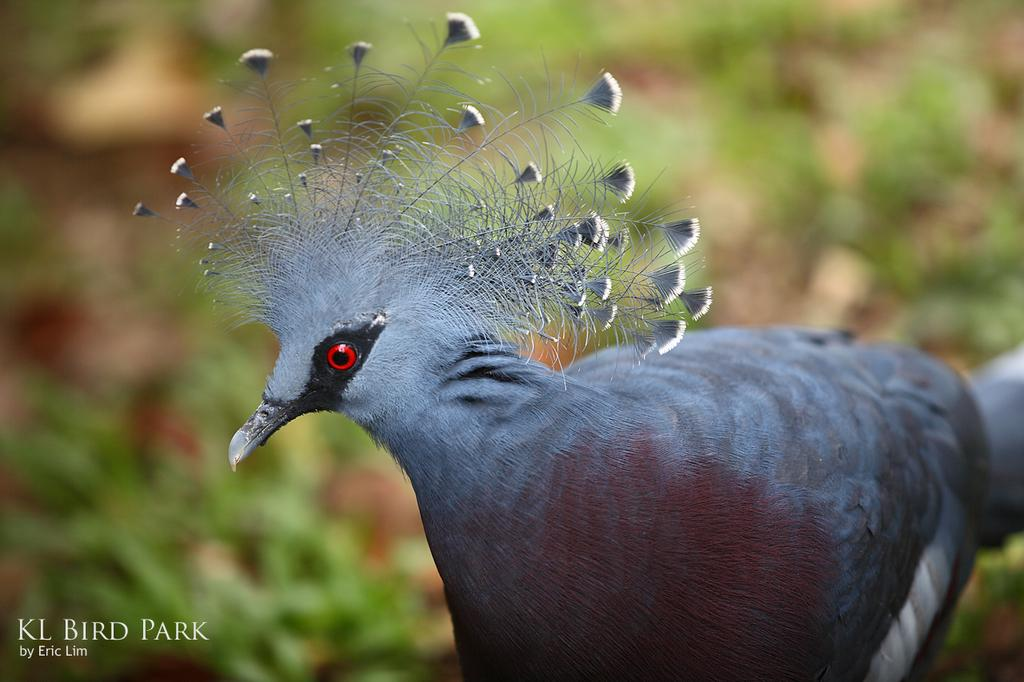What type of animal is the main subject of the image? There is a beautiful bird in the image. Can you describe the background of the image? The background of the image is blurred. What type of guide is the bird holding in the image? There is no guide present in the image; it features a beautiful bird with a blurred background. How many hens can be seen in the image? There are no hens present in the image; it features a beautiful bird. 